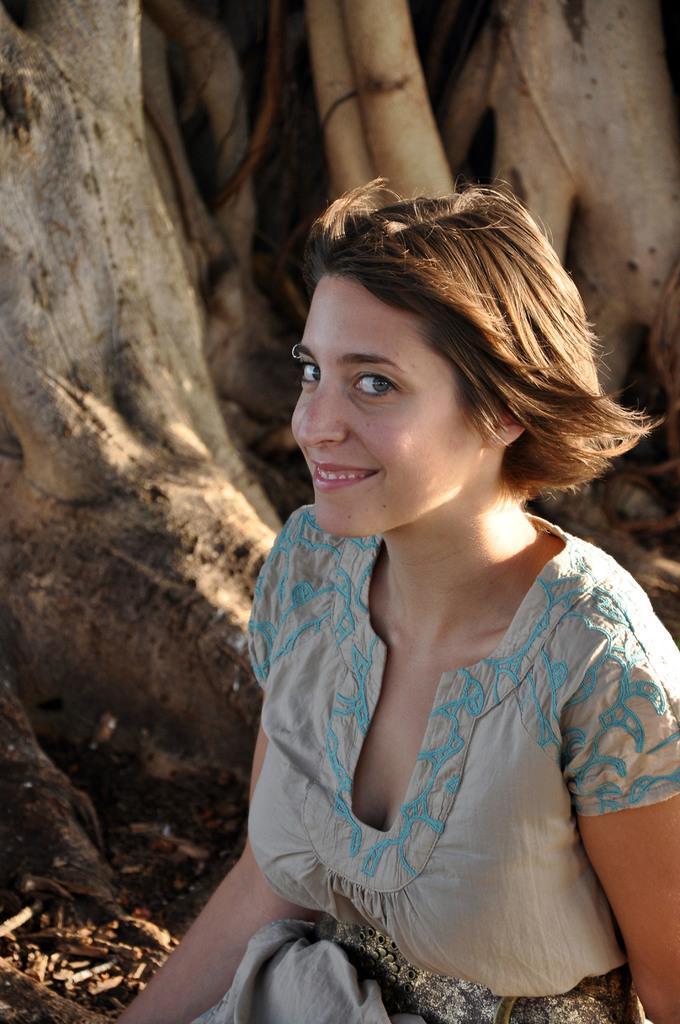Could you give a brief overview of what you see in this image? In this image I can see a woman in the front and I can also see smile on her face. In the background I can see few things. 